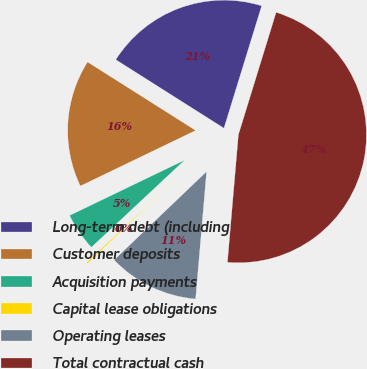Convert chart to OTSL. <chart><loc_0><loc_0><loc_500><loc_500><pie_chart><fcel>Long-term debt (including<fcel>Customer deposits<fcel>Acquisition payments<fcel>Capital lease obligations<fcel>Operating leases<fcel>Total contractual cash<nl><fcel>20.77%<fcel>16.13%<fcel>4.82%<fcel>0.18%<fcel>11.49%<fcel>46.6%<nl></chart> 